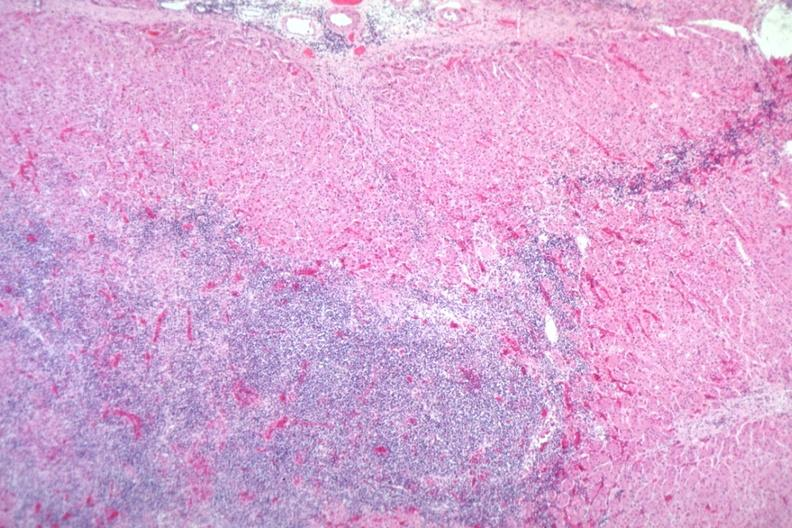does this image show easily seen infiltrate?
Answer the question using a single word or phrase. Yes 